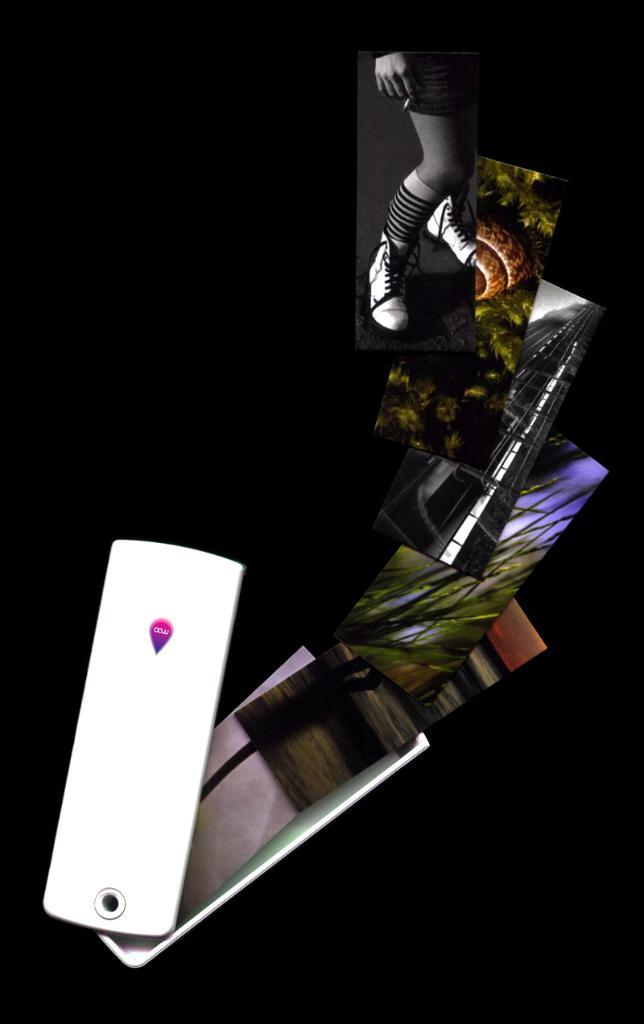What type of image is being described? The image is animated. What objects are present in the image? There are mobile phones in the image. What color is the background of the image? The background of the image is black. What type of berry is being painted by the doctor in the image? There is no berry or doctor present in the image; it only features animated mobile phones against a black background. 